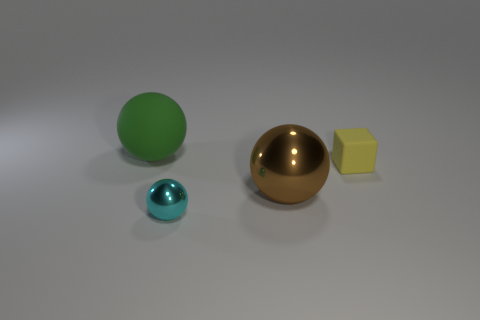Subtract all purple cubes. Subtract all green balls. How many cubes are left? 1 Add 1 small yellow cubes. How many objects exist? 5 Subtract all cubes. How many objects are left? 3 Add 4 big red balls. How many big red balls exist? 4 Subtract 0 cyan cylinders. How many objects are left? 4 Subtract all small yellow metal cubes. Subtract all tiny rubber cubes. How many objects are left? 3 Add 1 yellow things. How many yellow things are left? 2 